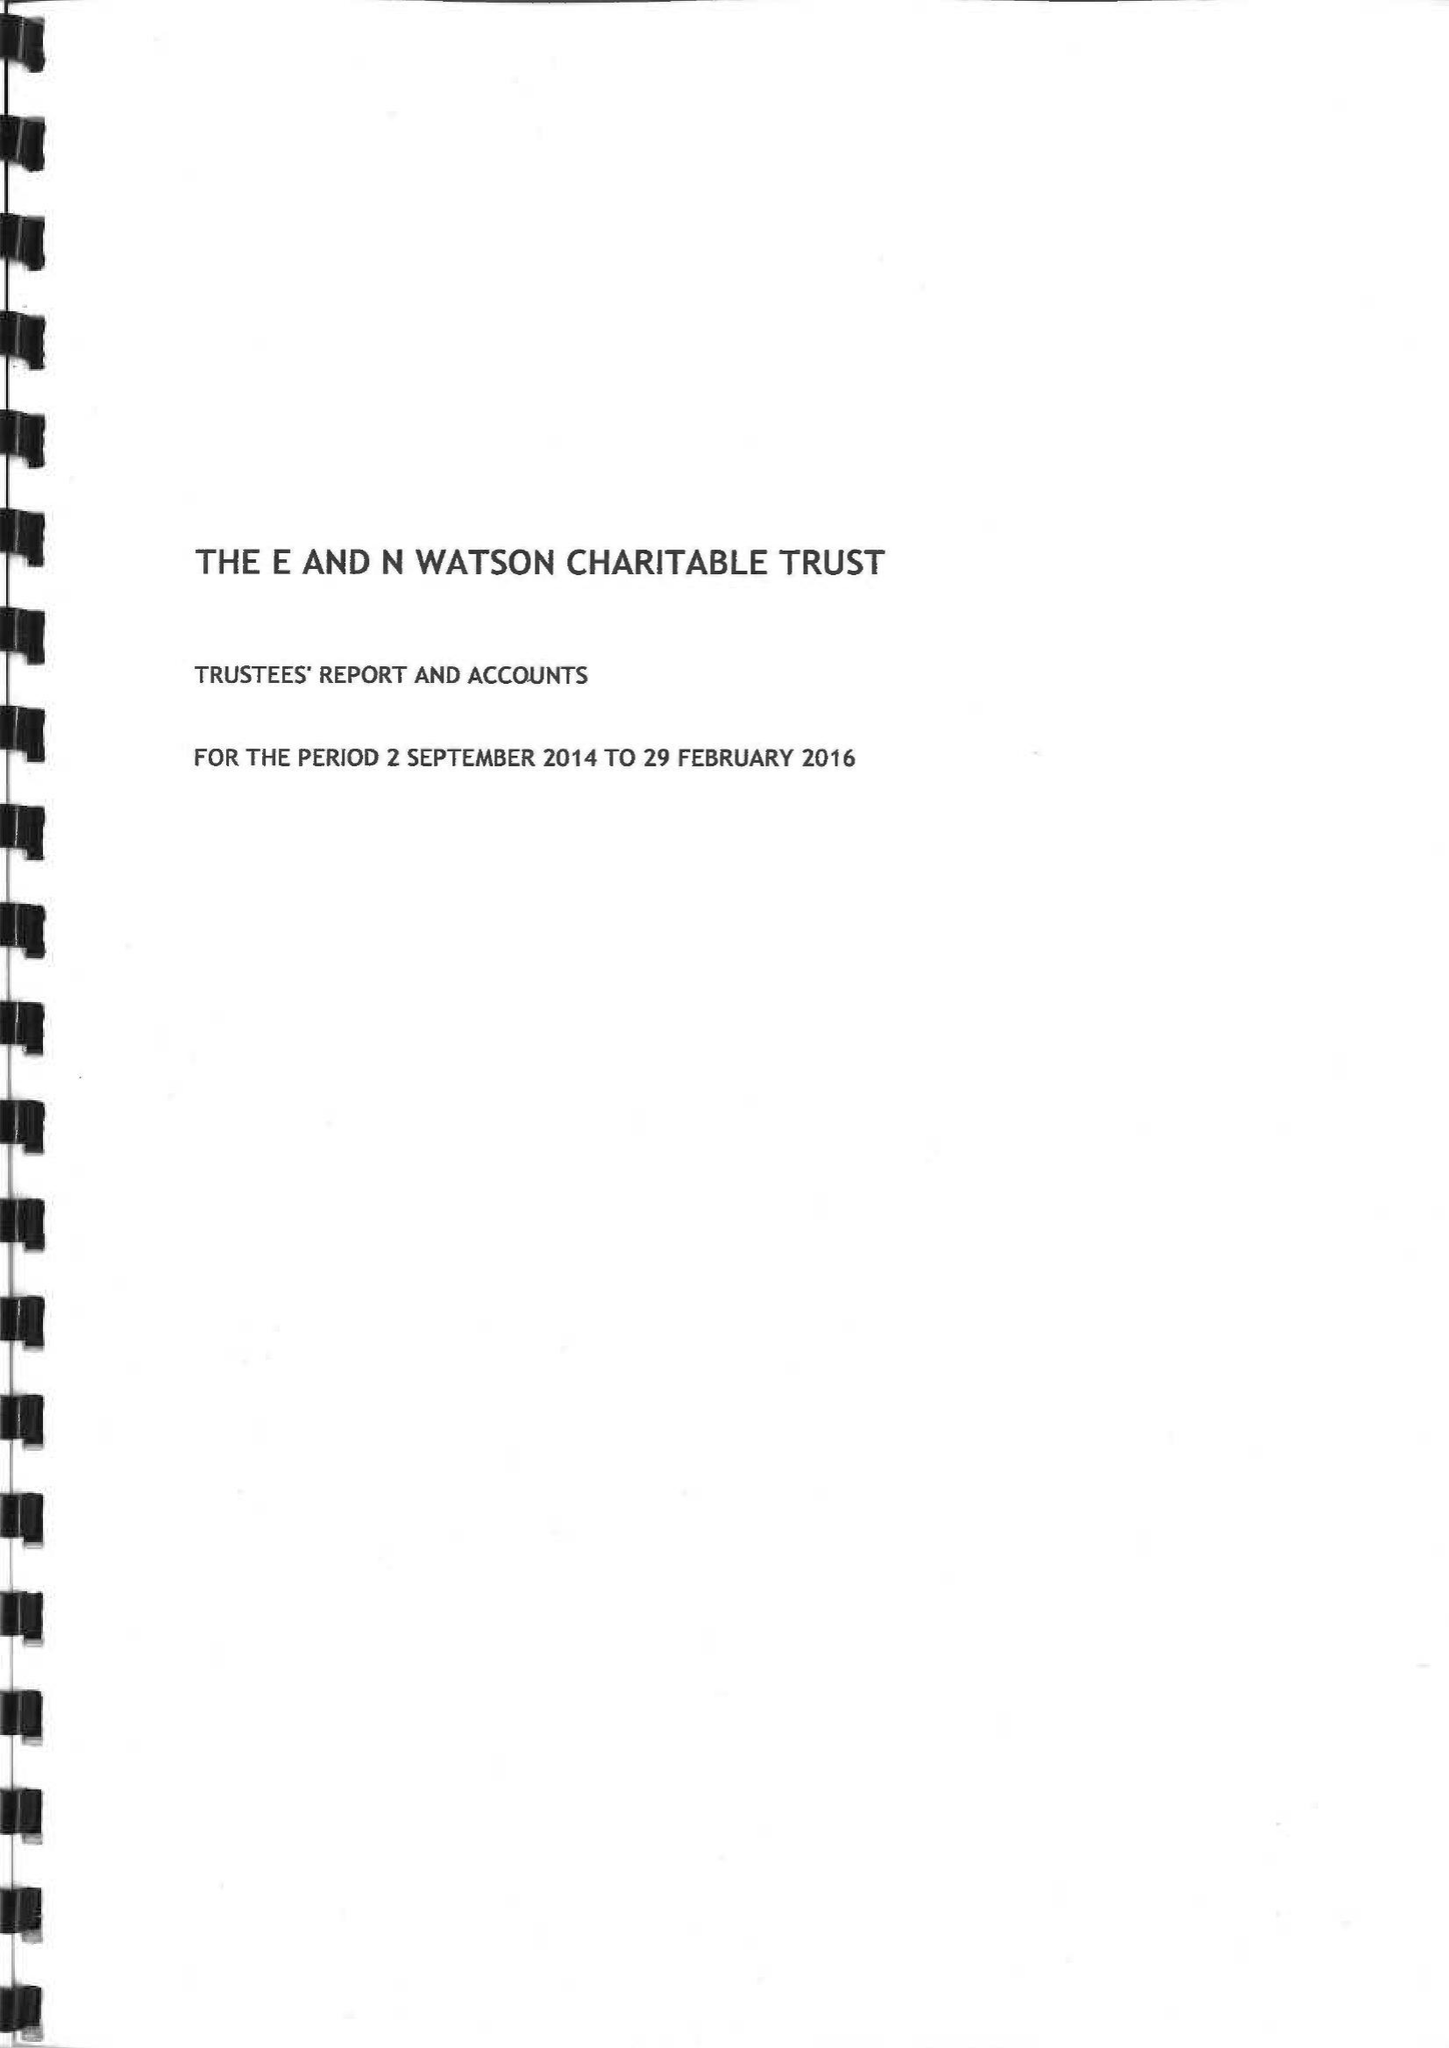What is the value for the spending_annually_in_british_pounds?
Answer the question using a single word or phrase. 100236.00 